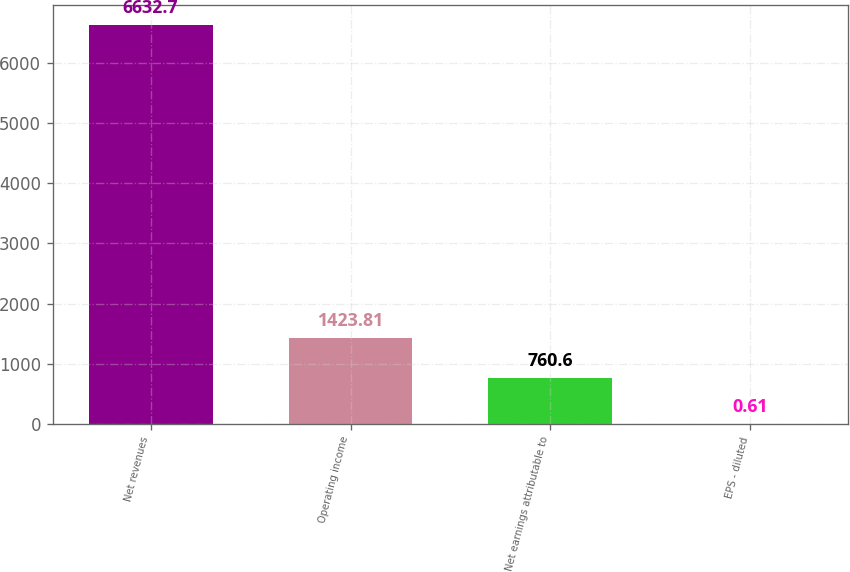<chart> <loc_0><loc_0><loc_500><loc_500><bar_chart><fcel>Net revenues<fcel>Operating income<fcel>Net earnings attributable to<fcel>EPS - diluted<nl><fcel>6632.7<fcel>1423.81<fcel>760.6<fcel>0.61<nl></chart> 